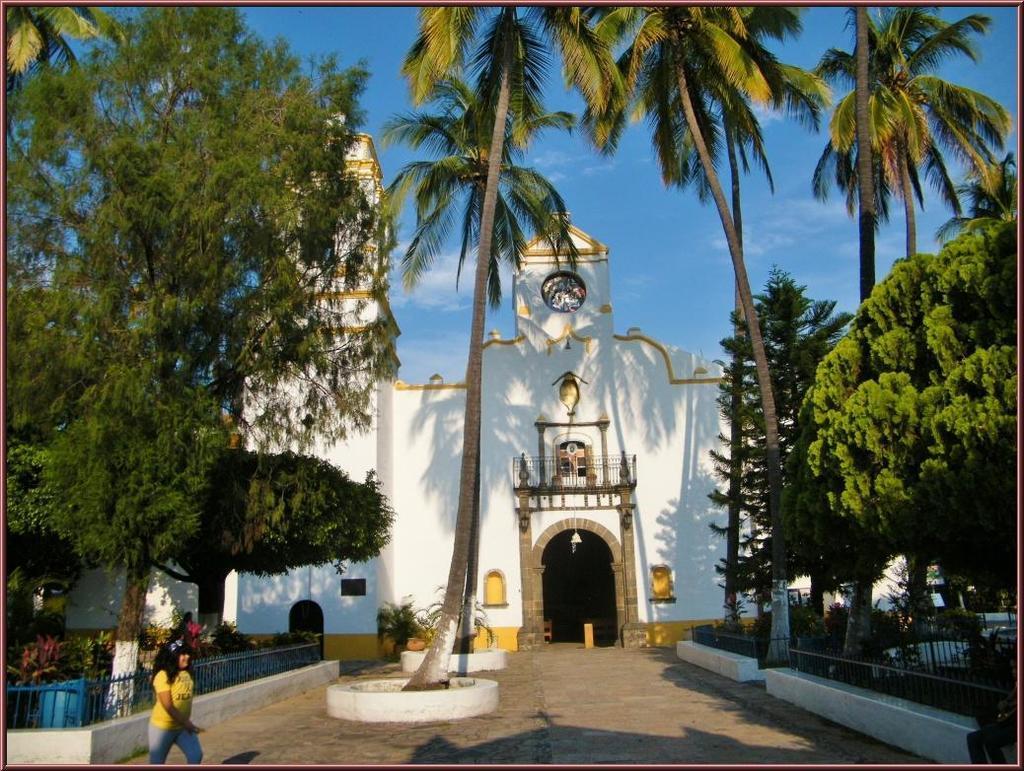Can you describe this image briefly? In this image, there is a building which is colored white. There trees on the left and on the right side of the image. There is a person on the bottom left of the image wearing clothes. In the background of the image, there is a sky. 